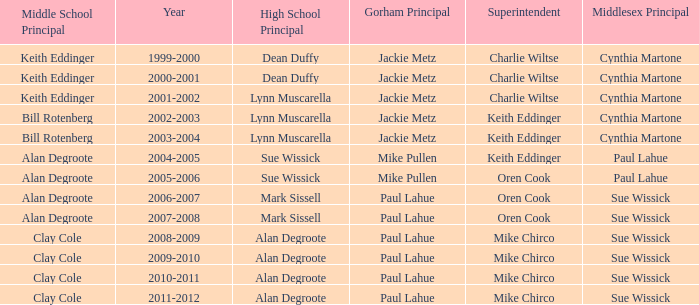Parse the full table. {'header': ['Middle School Principal', 'Year', 'High School Principal', 'Gorham Principal', 'Superintendent', 'Middlesex Principal'], 'rows': [['Keith Eddinger', '1999-2000', 'Dean Duffy', 'Jackie Metz', 'Charlie Wiltse', 'Cynthia Martone'], ['Keith Eddinger', '2000-2001', 'Dean Duffy', 'Jackie Metz', 'Charlie Wiltse', 'Cynthia Martone'], ['Keith Eddinger', '2001-2002', 'Lynn Muscarella', 'Jackie Metz', 'Charlie Wiltse', 'Cynthia Martone'], ['Bill Rotenberg', '2002-2003', 'Lynn Muscarella', 'Jackie Metz', 'Keith Eddinger', 'Cynthia Martone'], ['Bill Rotenberg', '2003-2004', 'Lynn Muscarella', 'Jackie Metz', 'Keith Eddinger', 'Cynthia Martone'], ['Alan Degroote', '2004-2005', 'Sue Wissick', 'Mike Pullen', 'Keith Eddinger', 'Paul Lahue'], ['Alan Degroote', '2005-2006', 'Sue Wissick', 'Mike Pullen', 'Oren Cook', 'Paul Lahue'], ['Alan Degroote', '2006-2007', 'Mark Sissell', 'Paul Lahue', 'Oren Cook', 'Sue Wissick'], ['Alan Degroote', '2007-2008', 'Mark Sissell', 'Paul Lahue', 'Oren Cook', 'Sue Wissick'], ['Clay Cole', '2008-2009', 'Alan Degroote', 'Paul Lahue', 'Mike Chirco', 'Sue Wissick'], ['Clay Cole', '2009-2010', 'Alan Degroote', 'Paul Lahue', 'Mike Chirco', 'Sue Wissick'], ['Clay Cole', '2010-2011', 'Alan Degroote', 'Paul Lahue', 'Mike Chirco', 'Sue Wissick'], ['Clay Cole', '2011-2012', 'Alan Degroote', 'Paul Lahue', 'Mike Chirco', 'Sue Wissick']]} How many high school principals were there in 2000-2001? Dean Duffy. 